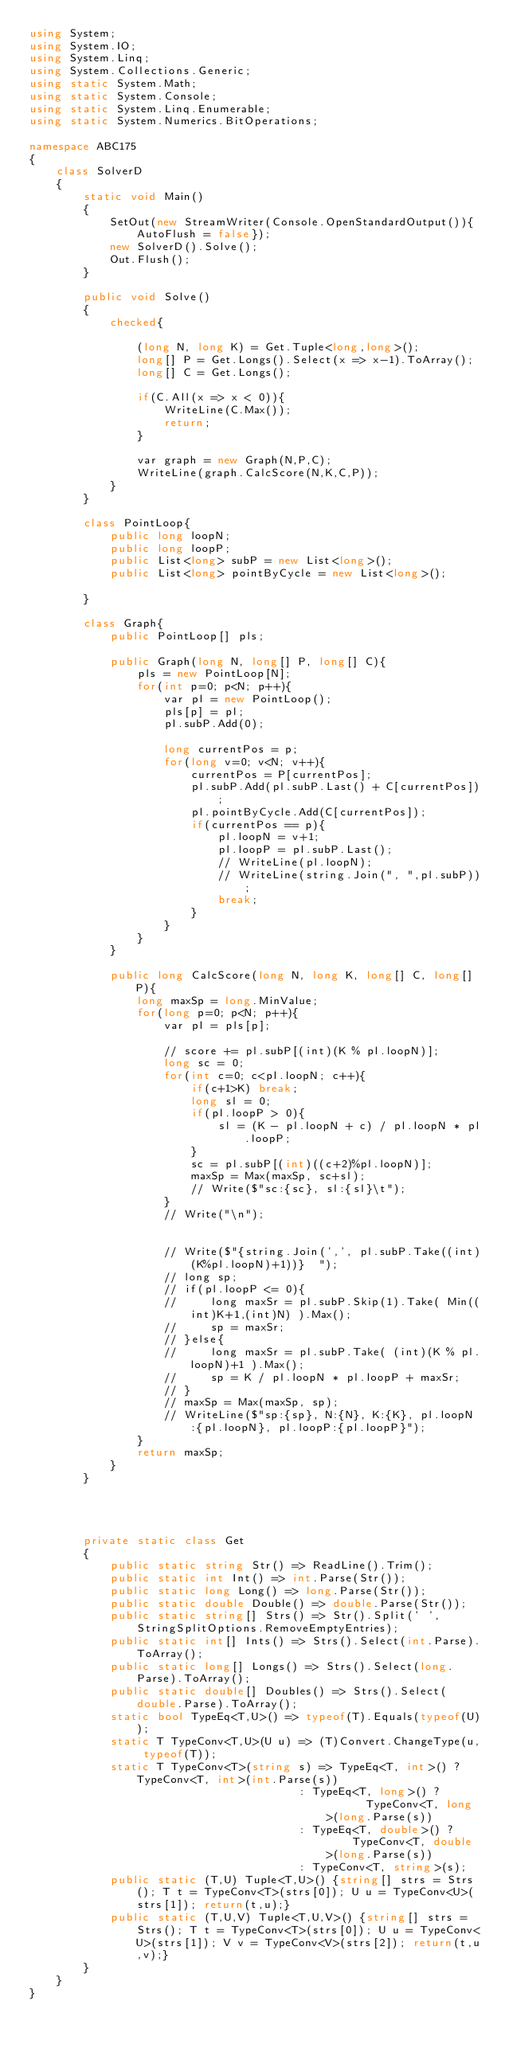<code> <loc_0><loc_0><loc_500><loc_500><_C#_>using System;
using System.IO;
using System.Linq;
using System.Collections.Generic;
using static System.Math;
using static System.Console;
using static System.Linq.Enumerable;
using static System.Numerics.BitOperations;

namespace ABC175
{
    class SolverD
    {
        static void Main()
        {
            SetOut(new StreamWriter(Console.OpenStandardOutput()){AutoFlush = false});
            new SolverD().Solve();
            Out.Flush();
        }

        public void Solve()
        {
            checked{
                
                (long N, long K) = Get.Tuple<long,long>();
                long[] P = Get.Longs().Select(x => x-1).ToArray();
                long[] C = Get.Longs();

                if(C.All(x => x < 0)){
                    WriteLine(C.Max());
                    return;
                }

                var graph = new Graph(N,P,C);
                WriteLine(graph.CalcScore(N,K,C,P));
            }
        }

        class PointLoop{
            public long loopN;
            public long loopP;
            public List<long> subP = new List<long>();
            public List<long> pointByCycle = new List<long>();

        }

        class Graph{
            public PointLoop[] pls;

            public Graph(long N, long[] P, long[] C){
                pls = new PointLoop[N];
                for(int p=0; p<N; p++){
                    var pl = new PointLoop();
                    pls[p] = pl;
                    pl.subP.Add(0);

                    long currentPos = p;
                    for(long v=0; v<N; v++){
                        currentPos = P[currentPos];
                        pl.subP.Add(pl.subP.Last() + C[currentPos]);
                        pl.pointByCycle.Add(C[currentPos]);
                        if(currentPos == p){
                            pl.loopN = v+1;
                            pl.loopP = pl.subP.Last();
                            // WriteLine(pl.loopN);
                            // WriteLine(string.Join(", ",pl.subP));
                            break;
                        }
                    }
                }
            }

            public long CalcScore(long N, long K, long[] C, long[] P){
                long maxSp = long.MinValue;
                for(long p=0; p<N; p++){
                    var pl = pls[p];

                    // score += pl.subP[(int)(K % pl.loopN)];
                    long sc = 0;
                    for(int c=0; c<pl.loopN; c++){
                        if(c+1>K) break;
                        long sl = 0;
                        if(pl.loopP > 0){
                            sl = (K - pl.loopN + c) / pl.loopN * pl.loopP;
                        }
                        sc = pl.subP[(int)((c+2)%pl.loopN)];
                        maxSp = Max(maxSp, sc+sl);
                        // Write($"sc:{sc}, sl:{sl}\t");
                    }
                    // Write("\n");
                    
                    
                    // Write($"{string.Join(',', pl.subP.Take((int)(K%pl.loopN)+1))}  ");
                    // long sp;
                    // if(pl.loopP <= 0){
                    //     long maxSr = pl.subP.Skip(1).Take( Min((int)K+1,(int)N) ).Max();
                    //     sp = maxSr;
                    // }else{
                    //     long maxSr = pl.subP.Take( (int)(K % pl.loopN)+1 ).Max();
                    //     sp = K / pl.loopN * pl.loopP + maxSr;
                    // }
                    // maxSp = Max(maxSp, sp);
                    // WriteLine($"sp:{sp}, N:{N}, K:{K}, pl.loopN:{pl.loopN}, pl.loopP:{pl.loopP}");
                }
                return maxSp;
            }
        }
        



        private static class Get
        {
            public static string Str() => ReadLine().Trim();
            public static int Int() => int.Parse(Str());
            public static long Long() => long.Parse(Str());
            public static double Double() => double.Parse(Str());
            public static string[] Strs() => Str().Split(' ', StringSplitOptions.RemoveEmptyEntries);
            public static int[] Ints() => Strs().Select(int.Parse).ToArray();
            public static long[] Longs() => Strs().Select(long.Parse).ToArray();
            public static double[] Doubles() => Strs().Select(double.Parse).ToArray();
            static bool TypeEq<T,U>() => typeof(T).Equals(typeof(U));
            static T TypeConv<T,U>(U u) => (T)Convert.ChangeType(u, typeof(T));
            static T TypeConv<T>(string s) => TypeEq<T, int>() ?   TypeConv<T, int>(int.Parse(s))
                                        : TypeEq<T, long>() ?       TypeConv<T, long>(long.Parse(s))
                                        : TypeEq<T, double>() ?     TypeConv<T, double>(long.Parse(s))
                                        : TypeConv<T, string>(s);
            public static (T,U) Tuple<T,U>() {string[] strs = Strs(); T t = TypeConv<T>(strs[0]); U u = TypeConv<U>(strs[1]); return(t,u);}
            public static (T,U,V) Tuple<T,U,V>() {string[] strs = Strs(); T t = TypeConv<T>(strs[0]); U u = TypeConv<U>(strs[1]); V v = TypeConv<V>(strs[2]); return(t,u,v);}
        }
    }
}
</code> 